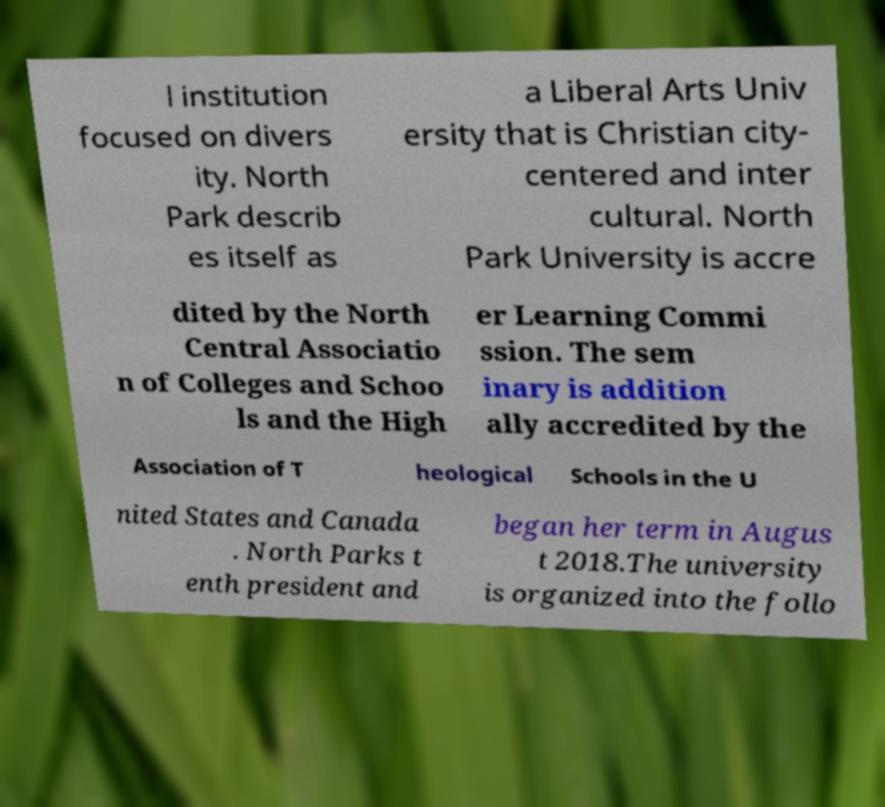Could you extract and type out the text from this image? l institution focused on divers ity. North Park describ es itself as a Liberal Arts Univ ersity that is Christian city- centered and inter cultural. North Park University is accre dited by the North Central Associatio n of Colleges and Schoo ls and the High er Learning Commi ssion. The sem inary is addition ally accredited by the Association of T heological Schools in the U nited States and Canada . North Parks t enth president and began her term in Augus t 2018.The university is organized into the follo 